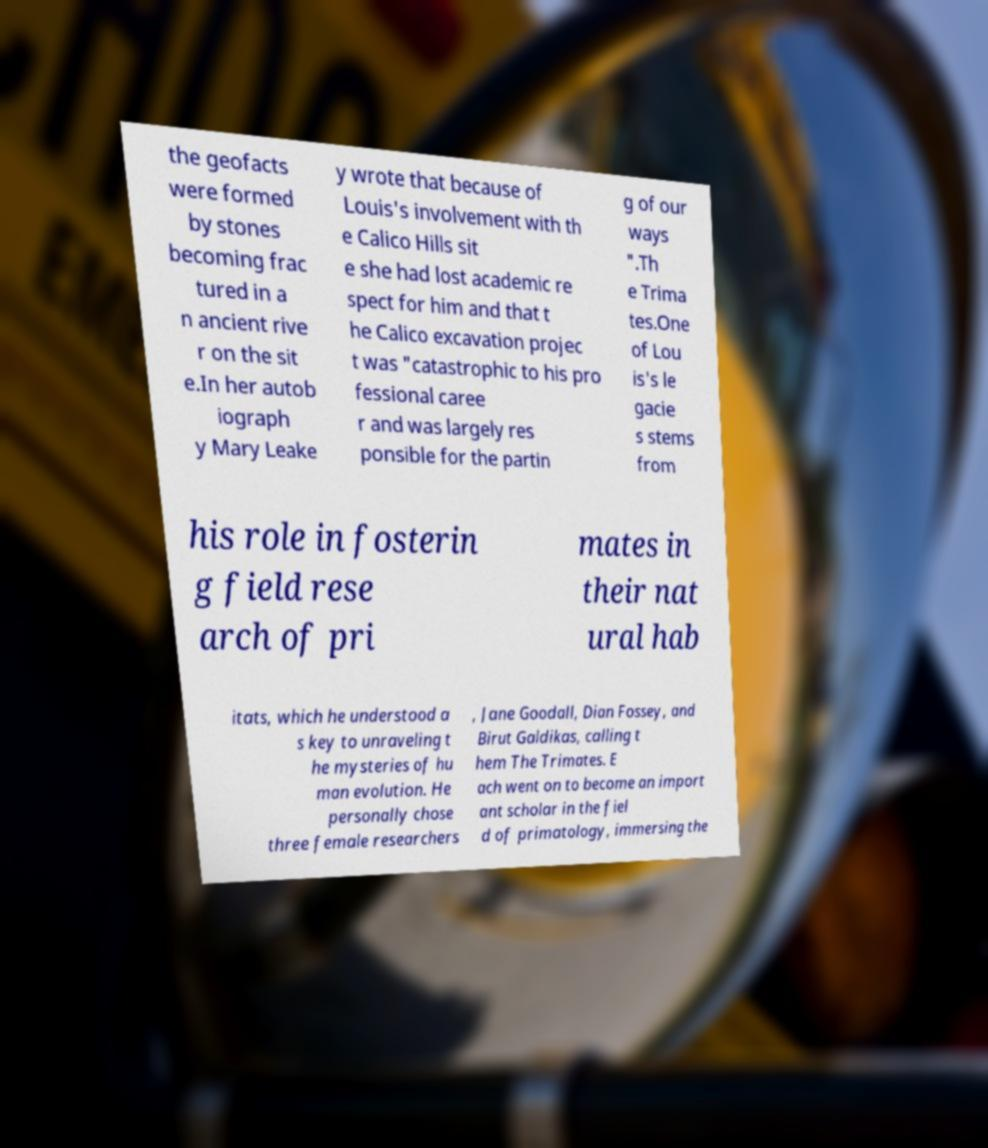Can you read and provide the text displayed in the image?This photo seems to have some interesting text. Can you extract and type it out for me? the geofacts were formed by stones becoming frac tured in a n ancient rive r on the sit e.In her autob iograph y Mary Leake y wrote that because of Louis's involvement with th e Calico Hills sit e she had lost academic re spect for him and that t he Calico excavation projec t was "catastrophic to his pro fessional caree r and was largely res ponsible for the partin g of our ways ".Th e Trima tes.One of Lou is's le gacie s stems from his role in fosterin g field rese arch of pri mates in their nat ural hab itats, which he understood a s key to unraveling t he mysteries of hu man evolution. He personally chose three female researchers , Jane Goodall, Dian Fossey, and Birut Galdikas, calling t hem The Trimates. E ach went on to become an import ant scholar in the fiel d of primatology, immersing the 